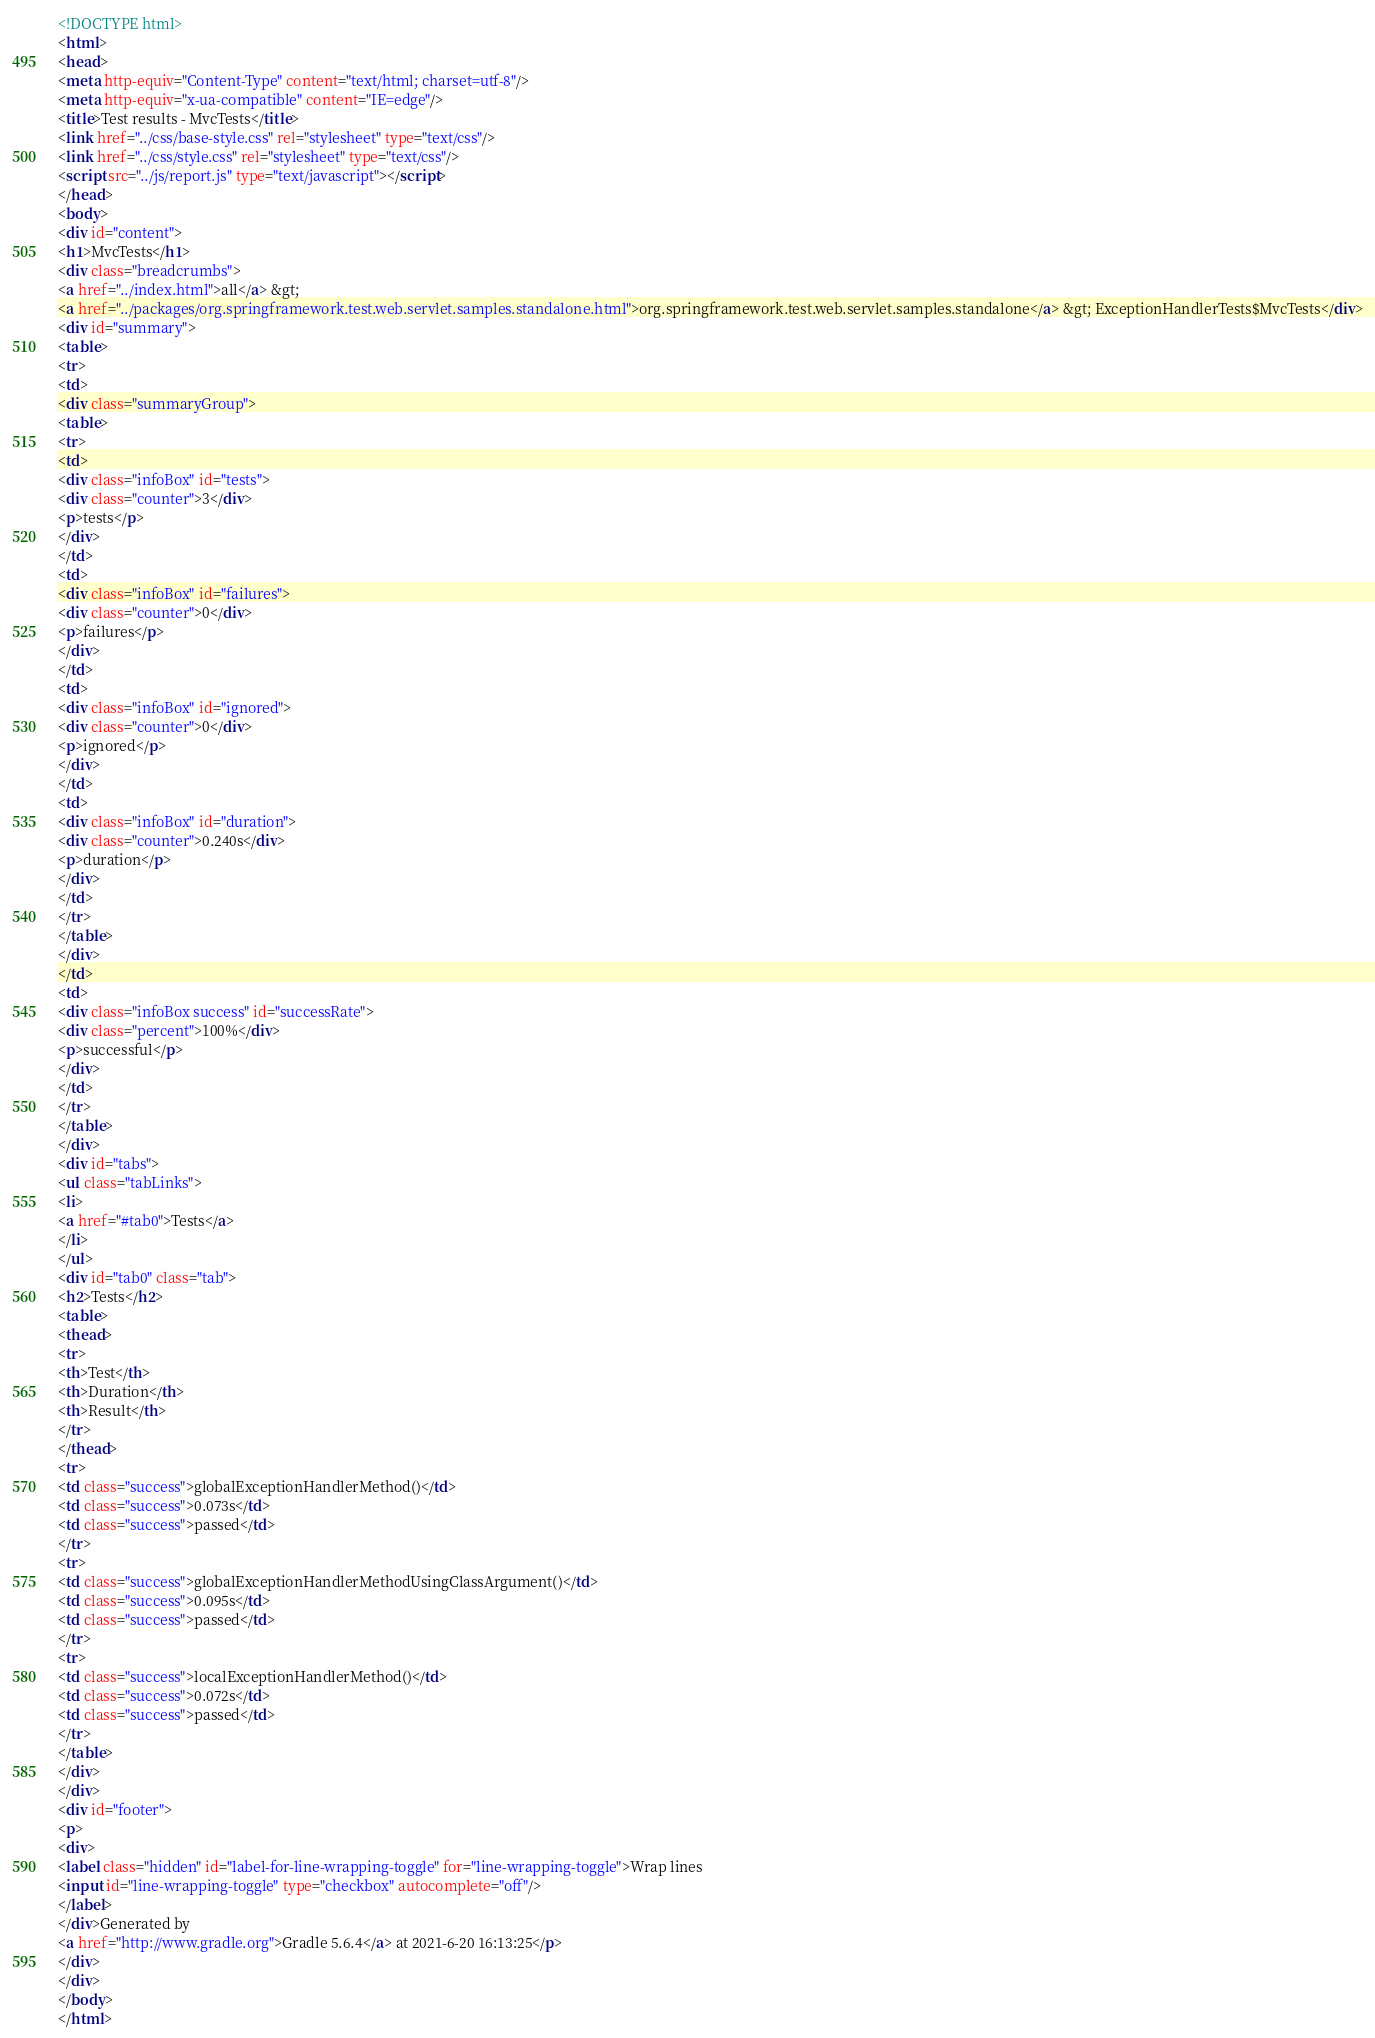<code> <loc_0><loc_0><loc_500><loc_500><_HTML_><!DOCTYPE html>
<html>
<head>
<meta http-equiv="Content-Type" content="text/html; charset=utf-8"/>
<meta http-equiv="x-ua-compatible" content="IE=edge"/>
<title>Test results - MvcTests</title>
<link href="../css/base-style.css" rel="stylesheet" type="text/css"/>
<link href="../css/style.css" rel="stylesheet" type="text/css"/>
<script src="../js/report.js" type="text/javascript"></script>
</head>
<body>
<div id="content">
<h1>MvcTests</h1>
<div class="breadcrumbs">
<a href="../index.html">all</a> &gt; 
<a href="../packages/org.springframework.test.web.servlet.samples.standalone.html">org.springframework.test.web.servlet.samples.standalone</a> &gt; ExceptionHandlerTests$MvcTests</div>
<div id="summary">
<table>
<tr>
<td>
<div class="summaryGroup">
<table>
<tr>
<td>
<div class="infoBox" id="tests">
<div class="counter">3</div>
<p>tests</p>
</div>
</td>
<td>
<div class="infoBox" id="failures">
<div class="counter">0</div>
<p>failures</p>
</div>
</td>
<td>
<div class="infoBox" id="ignored">
<div class="counter">0</div>
<p>ignored</p>
</div>
</td>
<td>
<div class="infoBox" id="duration">
<div class="counter">0.240s</div>
<p>duration</p>
</div>
</td>
</tr>
</table>
</div>
</td>
<td>
<div class="infoBox success" id="successRate">
<div class="percent">100%</div>
<p>successful</p>
</div>
</td>
</tr>
</table>
</div>
<div id="tabs">
<ul class="tabLinks">
<li>
<a href="#tab0">Tests</a>
</li>
</ul>
<div id="tab0" class="tab">
<h2>Tests</h2>
<table>
<thead>
<tr>
<th>Test</th>
<th>Duration</th>
<th>Result</th>
</tr>
</thead>
<tr>
<td class="success">globalExceptionHandlerMethod()</td>
<td class="success">0.073s</td>
<td class="success">passed</td>
</tr>
<tr>
<td class="success">globalExceptionHandlerMethodUsingClassArgument()</td>
<td class="success">0.095s</td>
<td class="success">passed</td>
</tr>
<tr>
<td class="success">localExceptionHandlerMethod()</td>
<td class="success">0.072s</td>
<td class="success">passed</td>
</tr>
</table>
</div>
</div>
<div id="footer">
<p>
<div>
<label class="hidden" id="label-for-line-wrapping-toggle" for="line-wrapping-toggle">Wrap lines
<input id="line-wrapping-toggle" type="checkbox" autocomplete="off"/>
</label>
</div>Generated by 
<a href="http://www.gradle.org">Gradle 5.6.4</a> at 2021-6-20 16:13:25</p>
</div>
</div>
</body>
</html>
</code> 